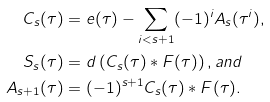<formula> <loc_0><loc_0><loc_500><loc_500>C _ { s } ( \tau ) & = e ( \tau ) - \sum _ { i < s + 1 } ( - 1 ) ^ { i } A _ { s } ( \tau ^ { i } ) , \\ S _ { s } ( \tau ) & = d \left ( C _ { s } ( \tau ) * F ( \tau ) \right ) , a n d \\ A _ { s + 1 } ( \tau ) & = ( - 1 ) ^ { s + 1 } C _ { s } ( \tau ) * F ( \tau ) .</formula> 